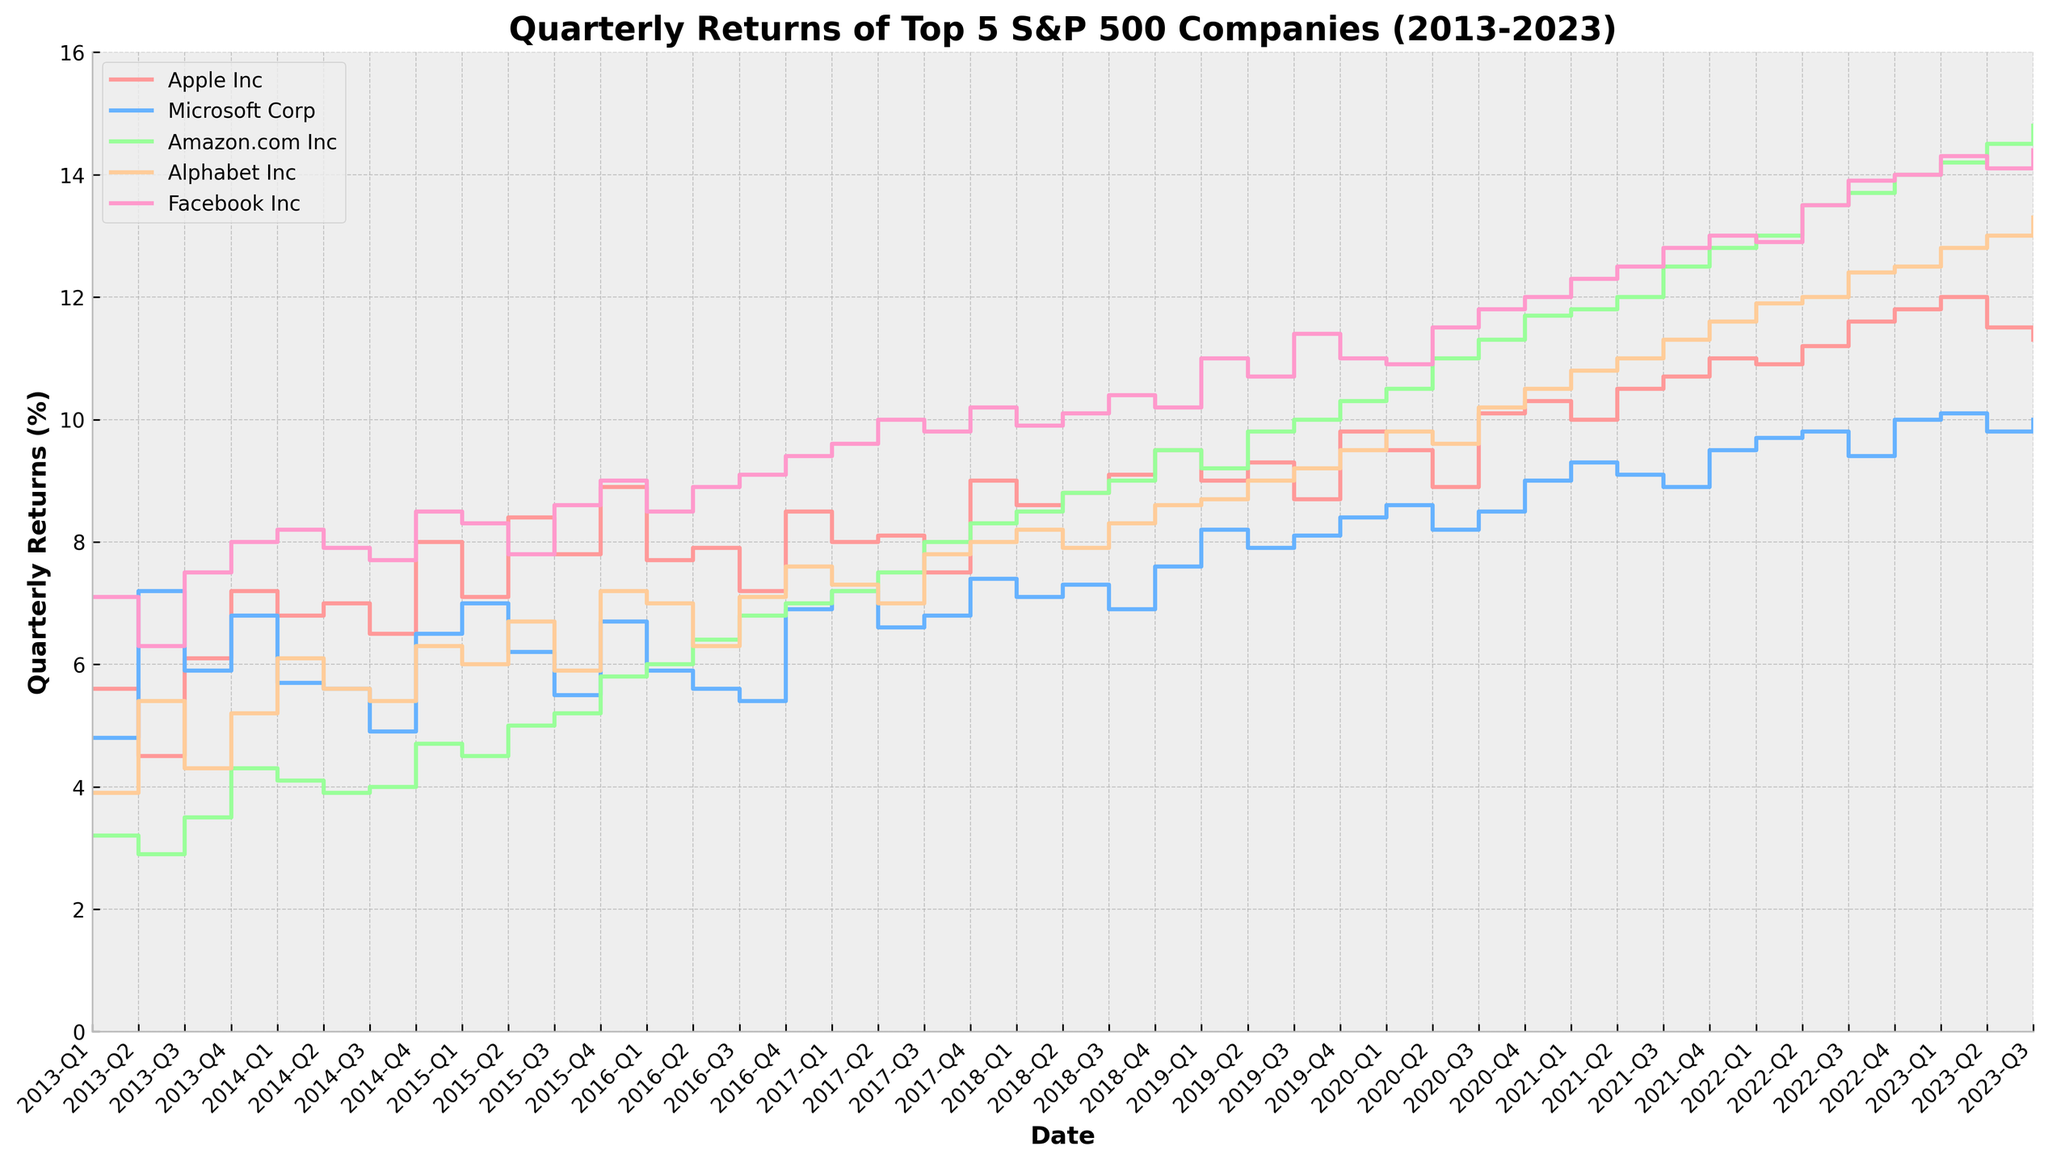What's the title of the figure? The title is displayed at the top of the figure. It reads "Quarterly Returns of Top 5 S&P 500 Companies (2013-2023)"
Answer: Quarterly Returns of Top 5 S&P 500 Companies (2013-2023) Which company shows the highest quarterly return at the end of the period (2023-Q3)? Examine the end of the period (2023-Q3) and compare the values for each company. Facebook Inc has the highest return of 14.4%
Answer: Facebook Inc How do the returns of Apple Inc and Microsoft Corp compare in 2017-Q4? Locate 2017-Q4 on the x-axis and compare the heights of the lines for Apple Inc and Microsoft Corp. Apple Inc has a return of 9.0% and Microsoft Corp has a return of 7.4%
Answer: Apple Inc's return is higher Which period shows the highest overall return for Amazon.com Inc? Scan through the entire plot and look for the peak value for Amazon.com Inc. It peaks at 14.8% in 2023-Q3
Answer: 2023-Q3 What is the trend of Alphabet Inc's returns from 2020-Q1 to 2022-Q1? Identify these periods and observe the direction of the line for Alphabet Inc. The returns generally increase from 9.8% to 11.9%
Answer: Increasing Between 2018-Q3 and 2019-Q3, did Facebook Inc's returns ever decrease? Examine the values at 2018-Q3 and 2019-Q3 for Facebook Inc. There’s a decrease from 10.4% in 2018-Q3 to 10.0% in 2019-Q2 before increasing again
Answer: Yes What is the average return for Microsoft Corp over the entire period shown? Sum all the quarterly returns for Microsoft Corp and divide by the number of quarters. The sum is 302.3% and there are 42 quarters, so the average is 302.3/42 = 7.19%
Answer: 7.19% Which company had the lowest minimum return in any quarter? Check the lowest points for each company's line on the graph. The lowest return is Intel Corp with 1.7% in 2013-Q2
Answer: Intel Corp How much did Apple's returns change from 2016-Q1 to 2019-Q1? Find the difference between the returns of these two quarters for Apple Inc. It's 9.0% in 2019-Q1 and 7.7% in 2016-Q1, so the change is 9.0 - 7.7 = 1.3%
Answer: 1.3% 